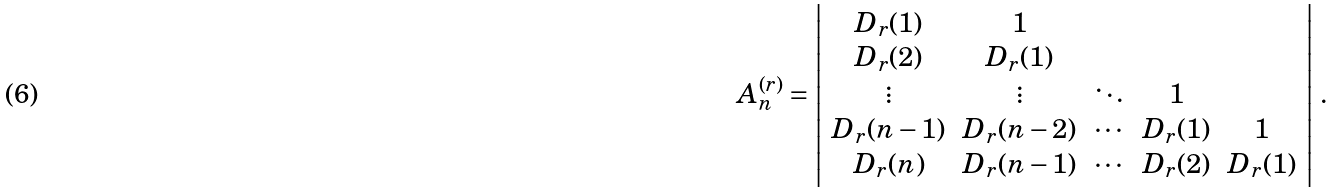Convert formula to latex. <formula><loc_0><loc_0><loc_500><loc_500>A _ { n } ^ { ( r ) } = \left | \begin{array} { c c c c c } D _ { r } ( 1 ) & 1 & & & \\ D _ { r } ( 2 ) & D _ { r } ( 1 ) & & & \\ \vdots & \vdots & \ddots & 1 & \\ D _ { r } ( n - 1 ) & D _ { r } ( n - 2 ) & \cdots & D _ { r } ( 1 ) & 1 \\ D _ { r } ( n ) & D _ { r } ( n - 1 ) & \cdots & D _ { r } ( 2 ) & D _ { r } ( 1 ) \end{array} \right | \, .</formula> 